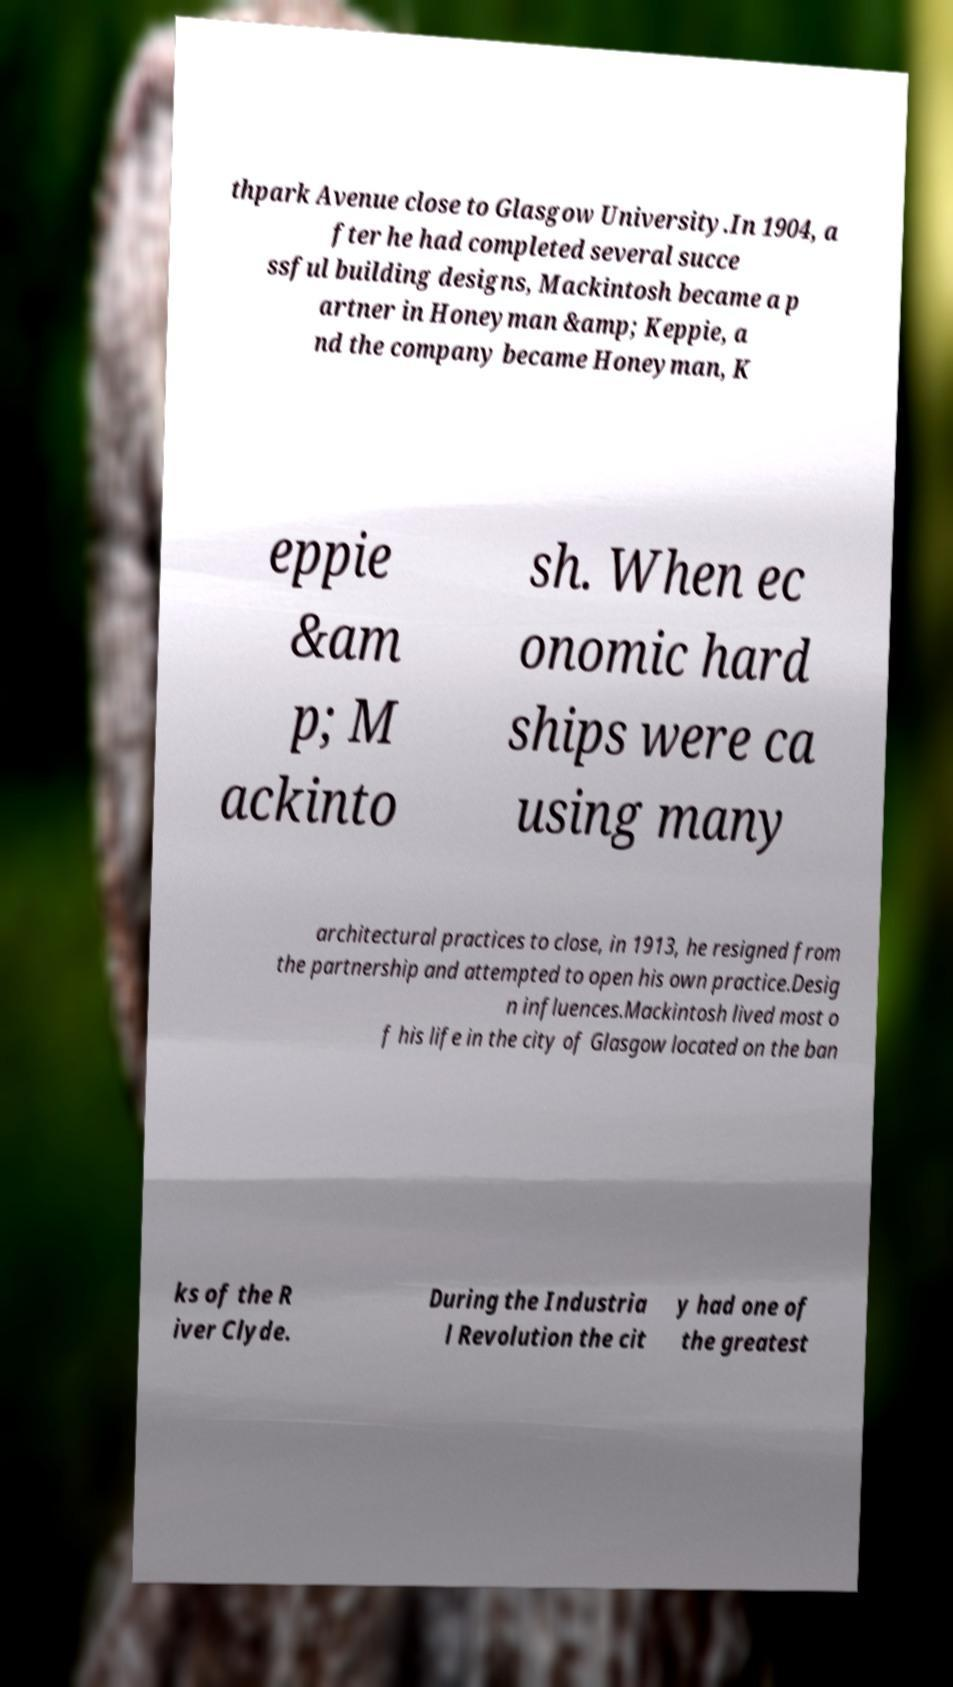Could you assist in decoding the text presented in this image and type it out clearly? thpark Avenue close to Glasgow University.In 1904, a fter he had completed several succe ssful building designs, Mackintosh became a p artner in Honeyman &amp; Keppie, a nd the company became Honeyman, K eppie &am p; M ackinto sh. When ec onomic hard ships were ca using many architectural practices to close, in 1913, he resigned from the partnership and attempted to open his own practice.Desig n influences.Mackintosh lived most o f his life in the city of Glasgow located on the ban ks of the R iver Clyde. During the Industria l Revolution the cit y had one of the greatest 